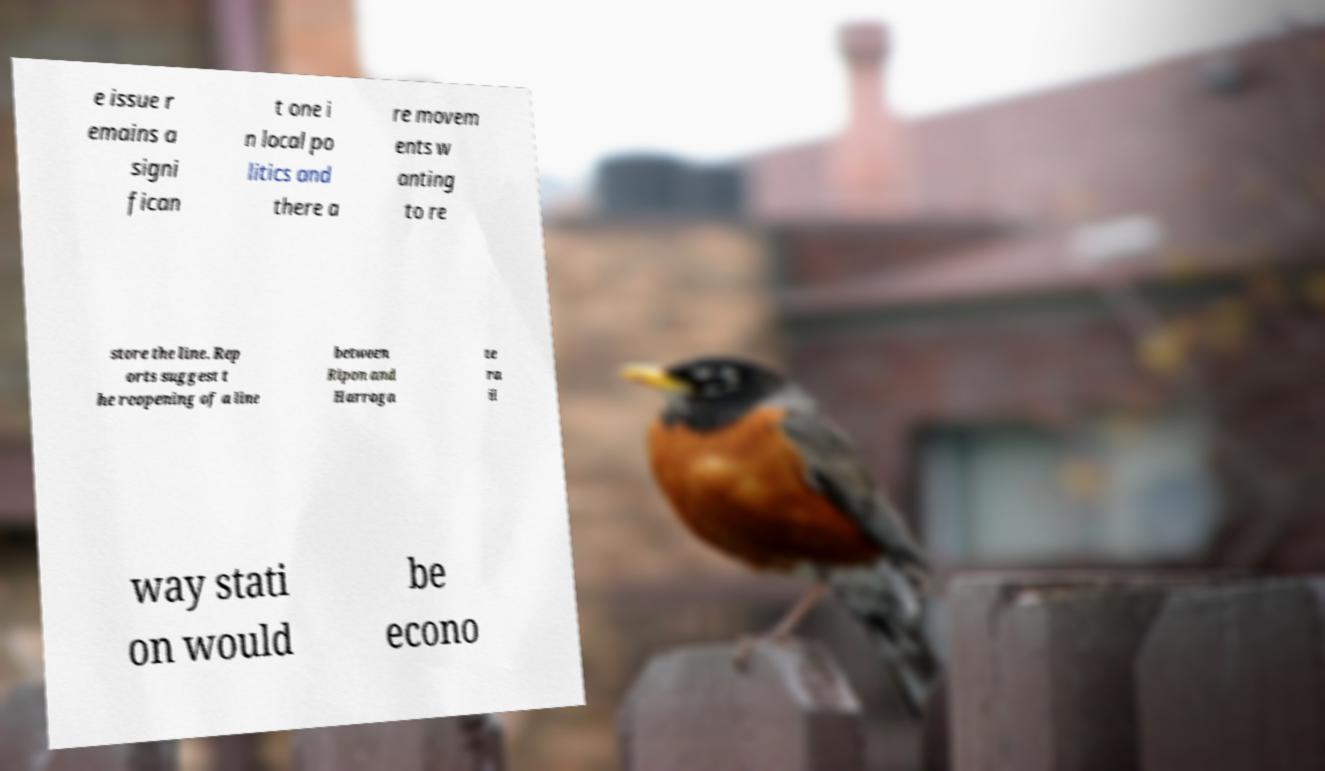Could you extract and type out the text from this image? e issue r emains a signi fican t one i n local po litics and there a re movem ents w anting to re store the line. Rep orts suggest t he reopening of a line between Ripon and Harroga te ra il way stati on would be econo 